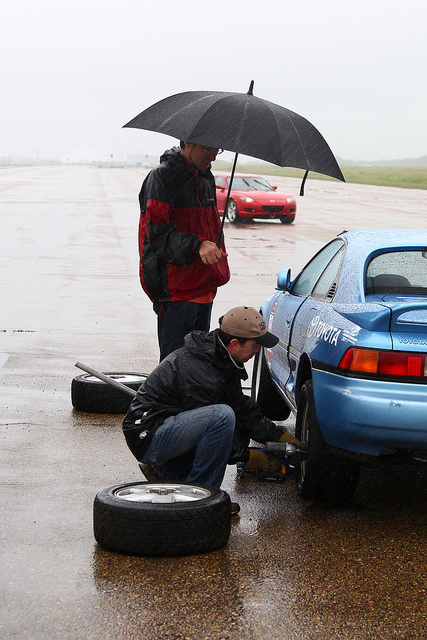Please transcribe the text information in this image. TOYOTA 